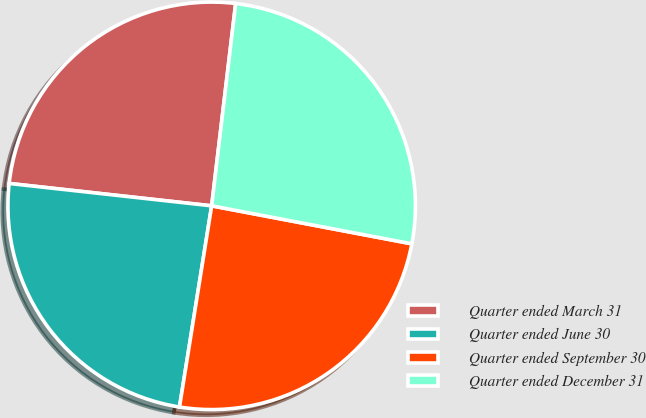<chart> <loc_0><loc_0><loc_500><loc_500><pie_chart><fcel>Quarter ended March 31<fcel>Quarter ended June 30<fcel>Quarter ended September 30<fcel>Quarter ended December 31<nl><fcel>25.13%<fcel>24.23%<fcel>24.54%<fcel>26.11%<nl></chart> 